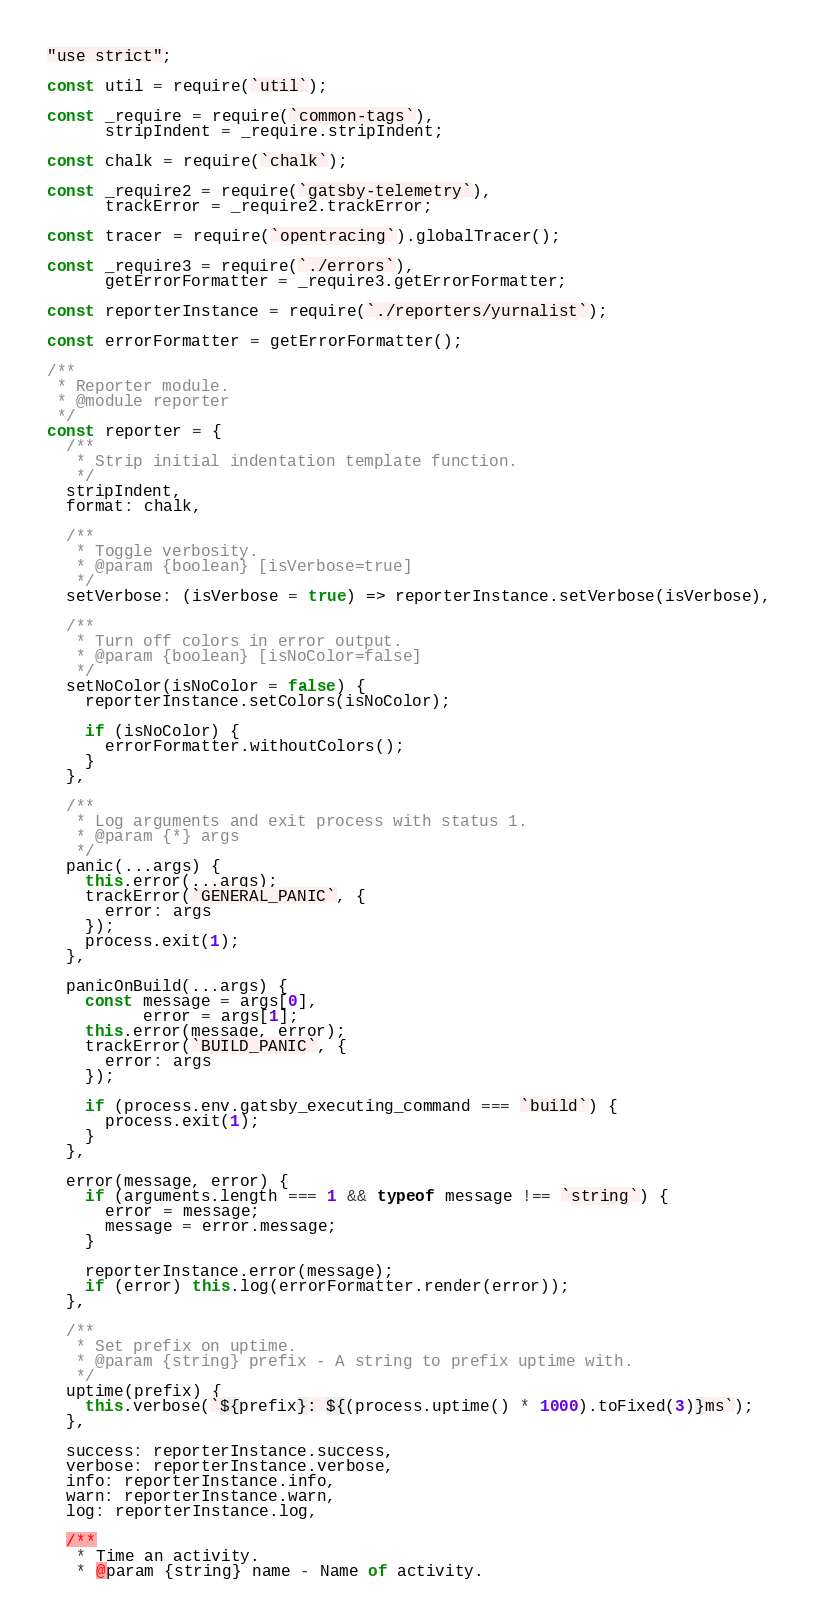Convert code to text. <code><loc_0><loc_0><loc_500><loc_500><_JavaScript_>"use strict";

const util = require(`util`);

const _require = require(`common-tags`),
      stripIndent = _require.stripIndent;

const chalk = require(`chalk`);

const _require2 = require(`gatsby-telemetry`),
      trackError = _require2.trackError;

const tracer = require(`opentracing`).globalTracer();

const _require3 = require(`./errors`),
      getErrorFormatter = _require3.getErrorFormatter;

const reporterInstance = require(`./reporters/yurnalist`);

const errorFormatter = getErrorFormatter();

/**
 * Reporter module.
 * @module reporter
 */
const reporter = {
  /**
   * Strip initial indentation template function.
   */
  stripIndent,
  format: chalk,

  /**
   * Toggle verbosity.
   * @param {boolean} [isVerbose=true]
   */
  setVerbose: (isVerbose = true) => reporterInstance.setVerbose(isVerbose),

  /**
   * Turn off colors in error output.
   * @param {boolean} [isNoColor=false]
   */
  setNoColor(isNoColor = false) {
    reporterInstance.setColors(isNoColor);

    if (isNoColor) {
      errorFormatter.withoutColors();
    }
  },

  /**
   * Log arguments and exit process with status 1.
   * @param {*} args
   */
  panic(...args) {
    this.error(...args);
    trackError(`GENERAL_PANIC`, {
      error: args
    });
    process.exit(1);
  },

  panicOnBuild(...args) {
    const message = args[0],
          error = args[1];
    this.error(message, error);
    trackError(`BUILD_PANIC`, {
      error: args
    });

    if (process.env.gatsby_executing_command === `build`) {
      process.exit(1);
    }
  },

  error(message, error) {
    if (arguments.length === 1 && typeof message !== `string`) {
      error = message;
      message = error.message;
    }

    reporterInstance.error(message);
    if (error) this.log(errorFormatter.render(error));
  },

  /**
   * Set prefix on uptime.
   * @param {string} prefix - A string to prefix uptime with.
   */
  uptime(prefix) {
    this.verbose(`${prefix}: ${(process.uptime() * 1000).toFixed(3)}ms`);
  },

  success: reporterInstance.success,
  verbose: reporterInstance.verbose,
  info: reporterInstance.info,
  warn: reporterInstance.warn,
  log: reporterInstance.log,

  /**
   * Time an activity.
   * @param {string} name - Name of activity.</code> 